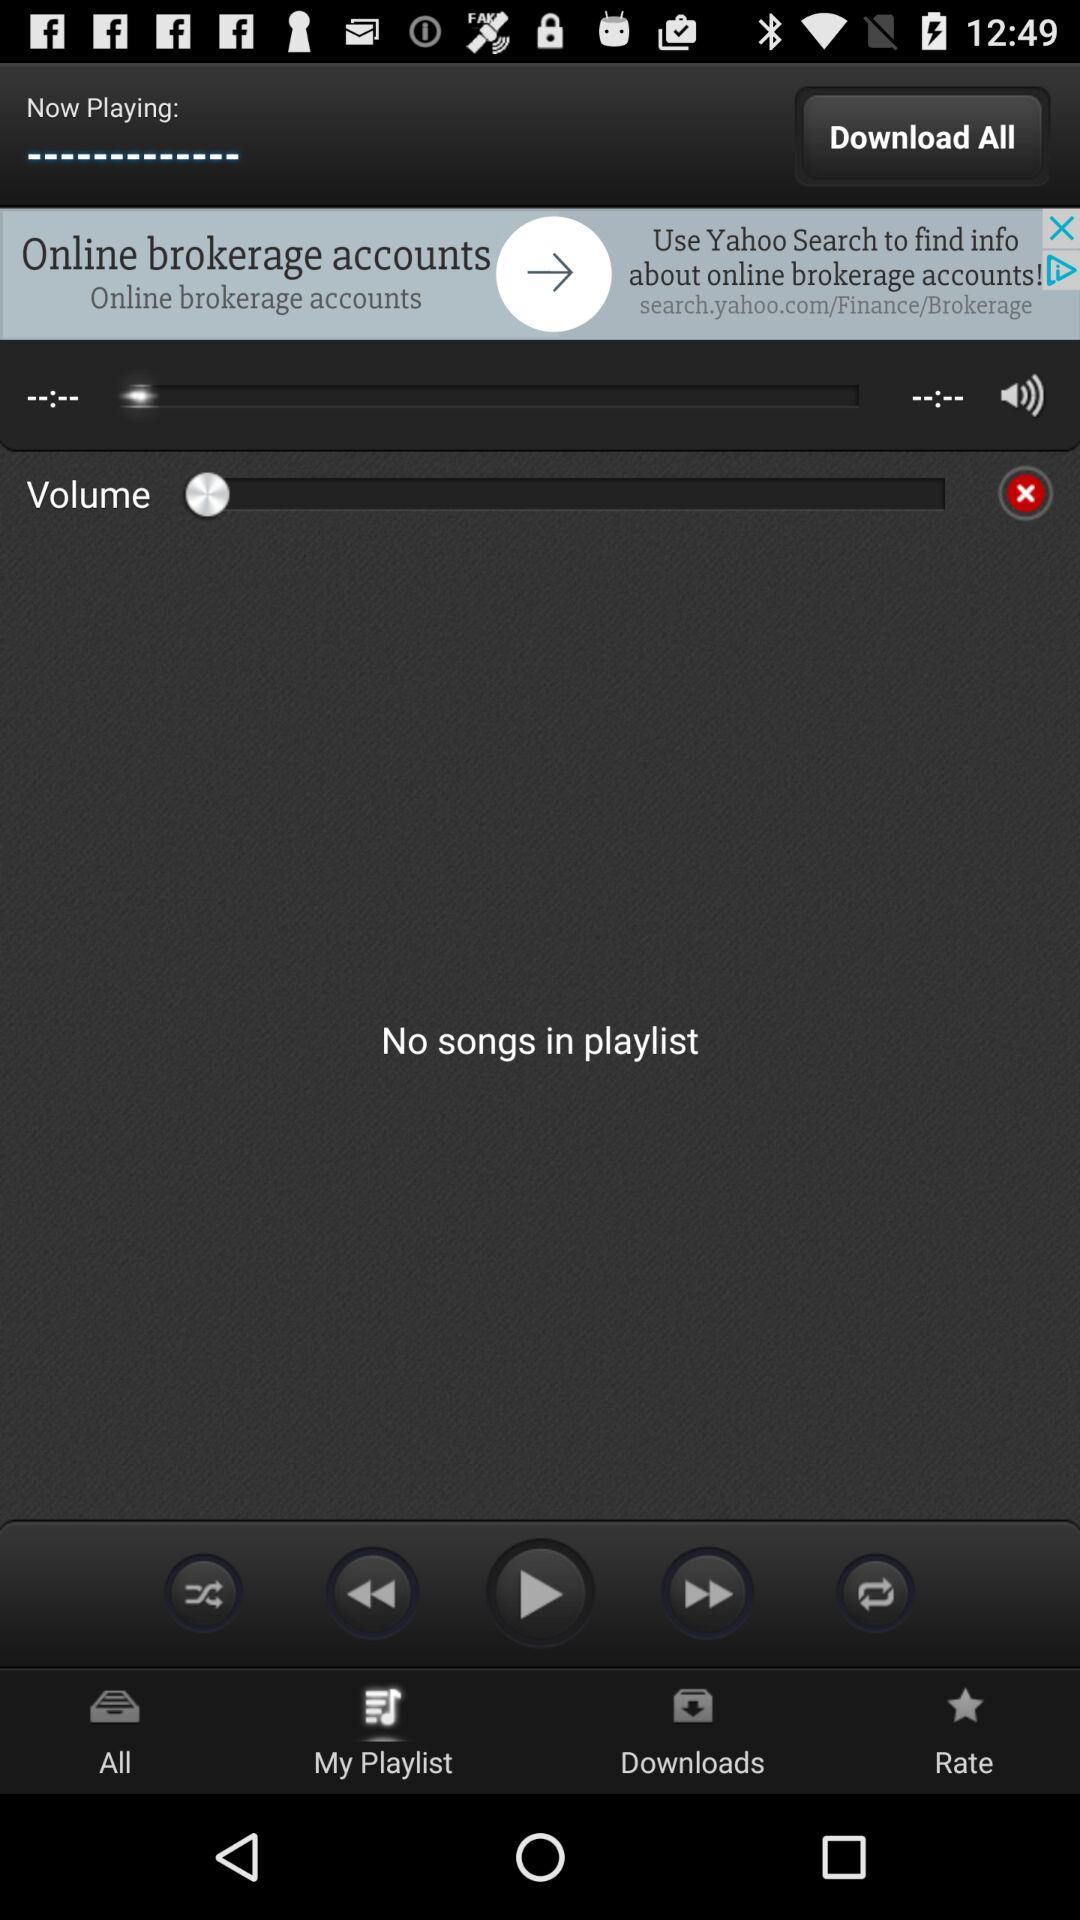Is there any song in the playlist? There is no song in the playlist. 